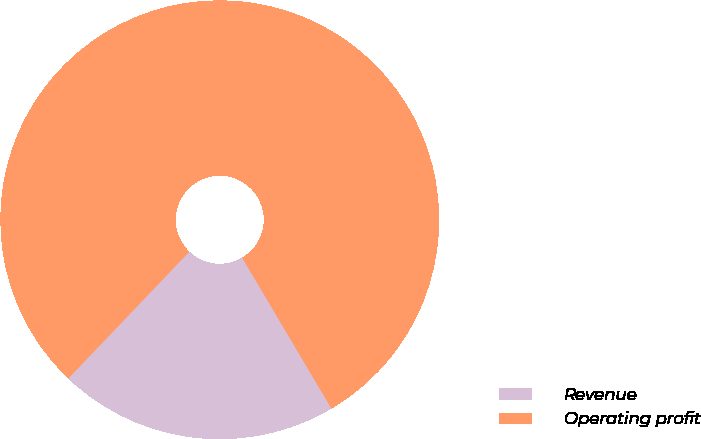<chart> <loc_0><loc_0><loc_500><loc_500><pie_chart><fcel>Revenue<fcel>Operating profit<nl><fcel>20.63%<fcel>79.37%<nl></chart> 